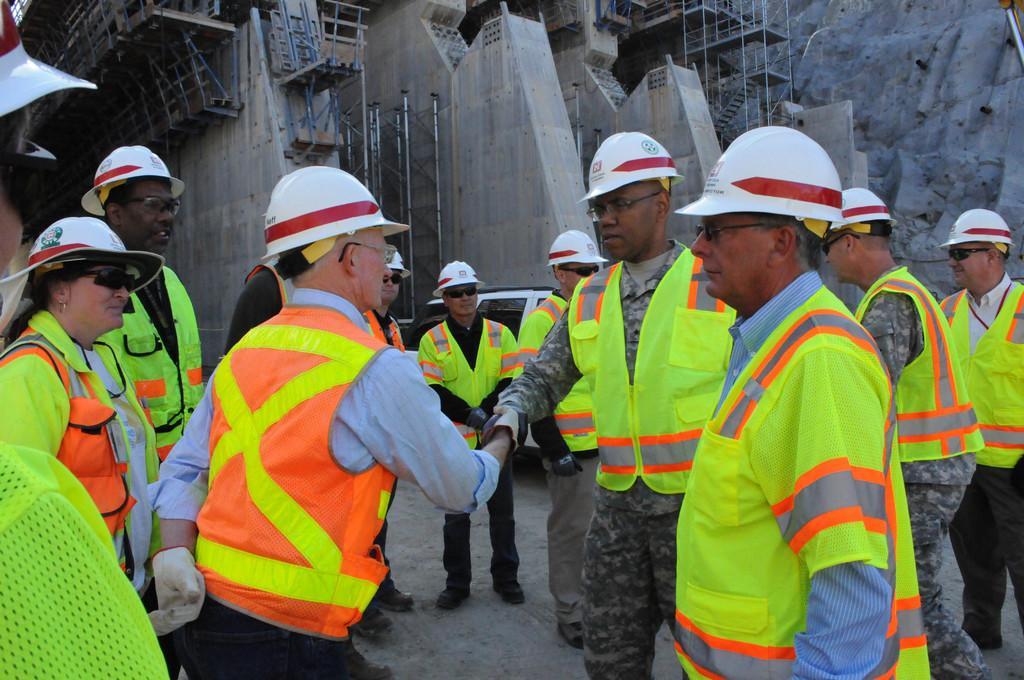Can you describe this image briefly? In this image we can see many people and all the people wearing helmets. There is a construction site in the image. There are few vehicles in the image. There are many metallic objects in the image. 